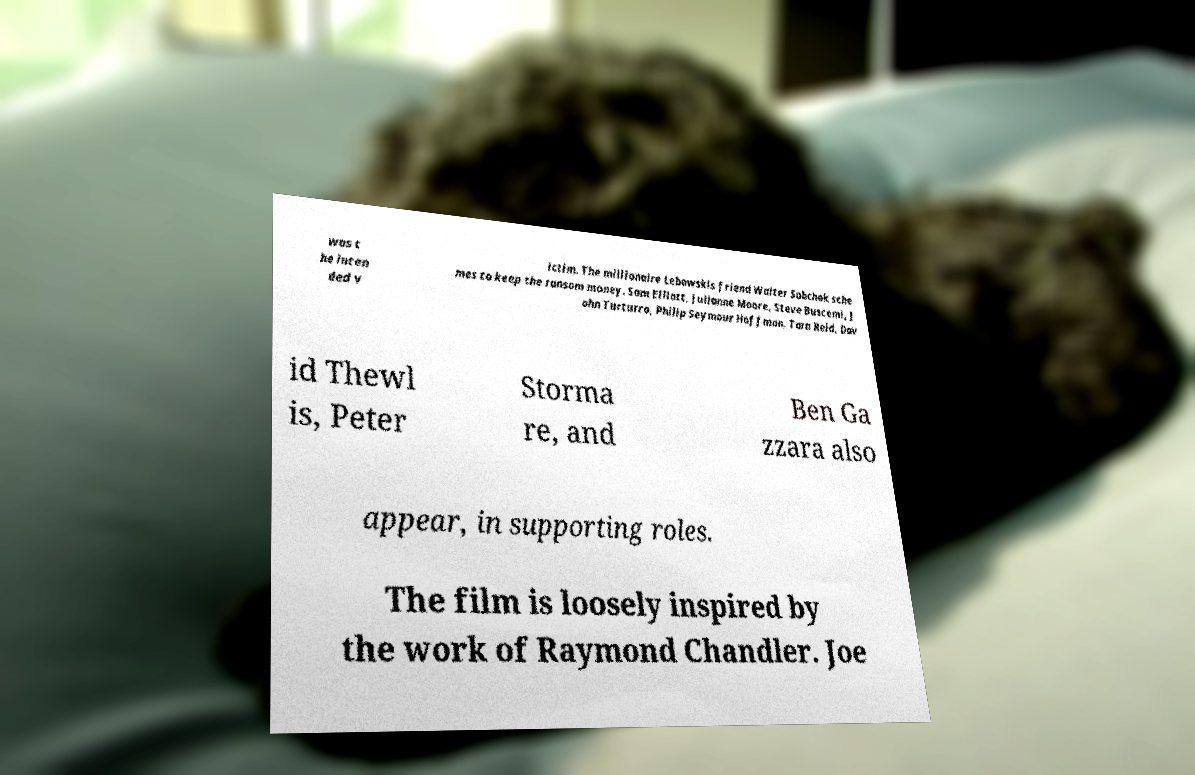Could you extract and type out the text from this image? was t he inten ded v ictim. The millionaire Lebowskis friend Walter Sobchak sche mes to keep the ransom money. Sam Elliott, Julianne Moore, Steve Buscemi, J ohn Turturro, Philip Seymour Hoffman, Tara Reid, Dav id Thewl is, Peter Storma re, and Ben Ga zzara also appear, in supporting roles. The film is loosely inspired by the work of Raymond Chandler. Joe 